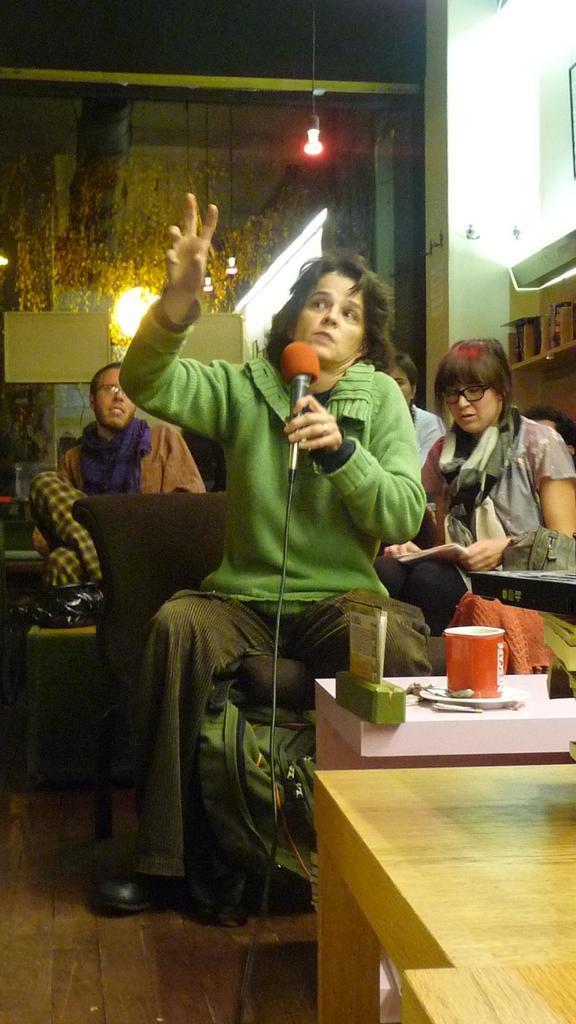In one or two sentences, can you explain what this image depicts? Here a woman is sitting and holding microphone in her hand,behind her there are few people and wall. In front of her there is a table,on the table there is a cup. 